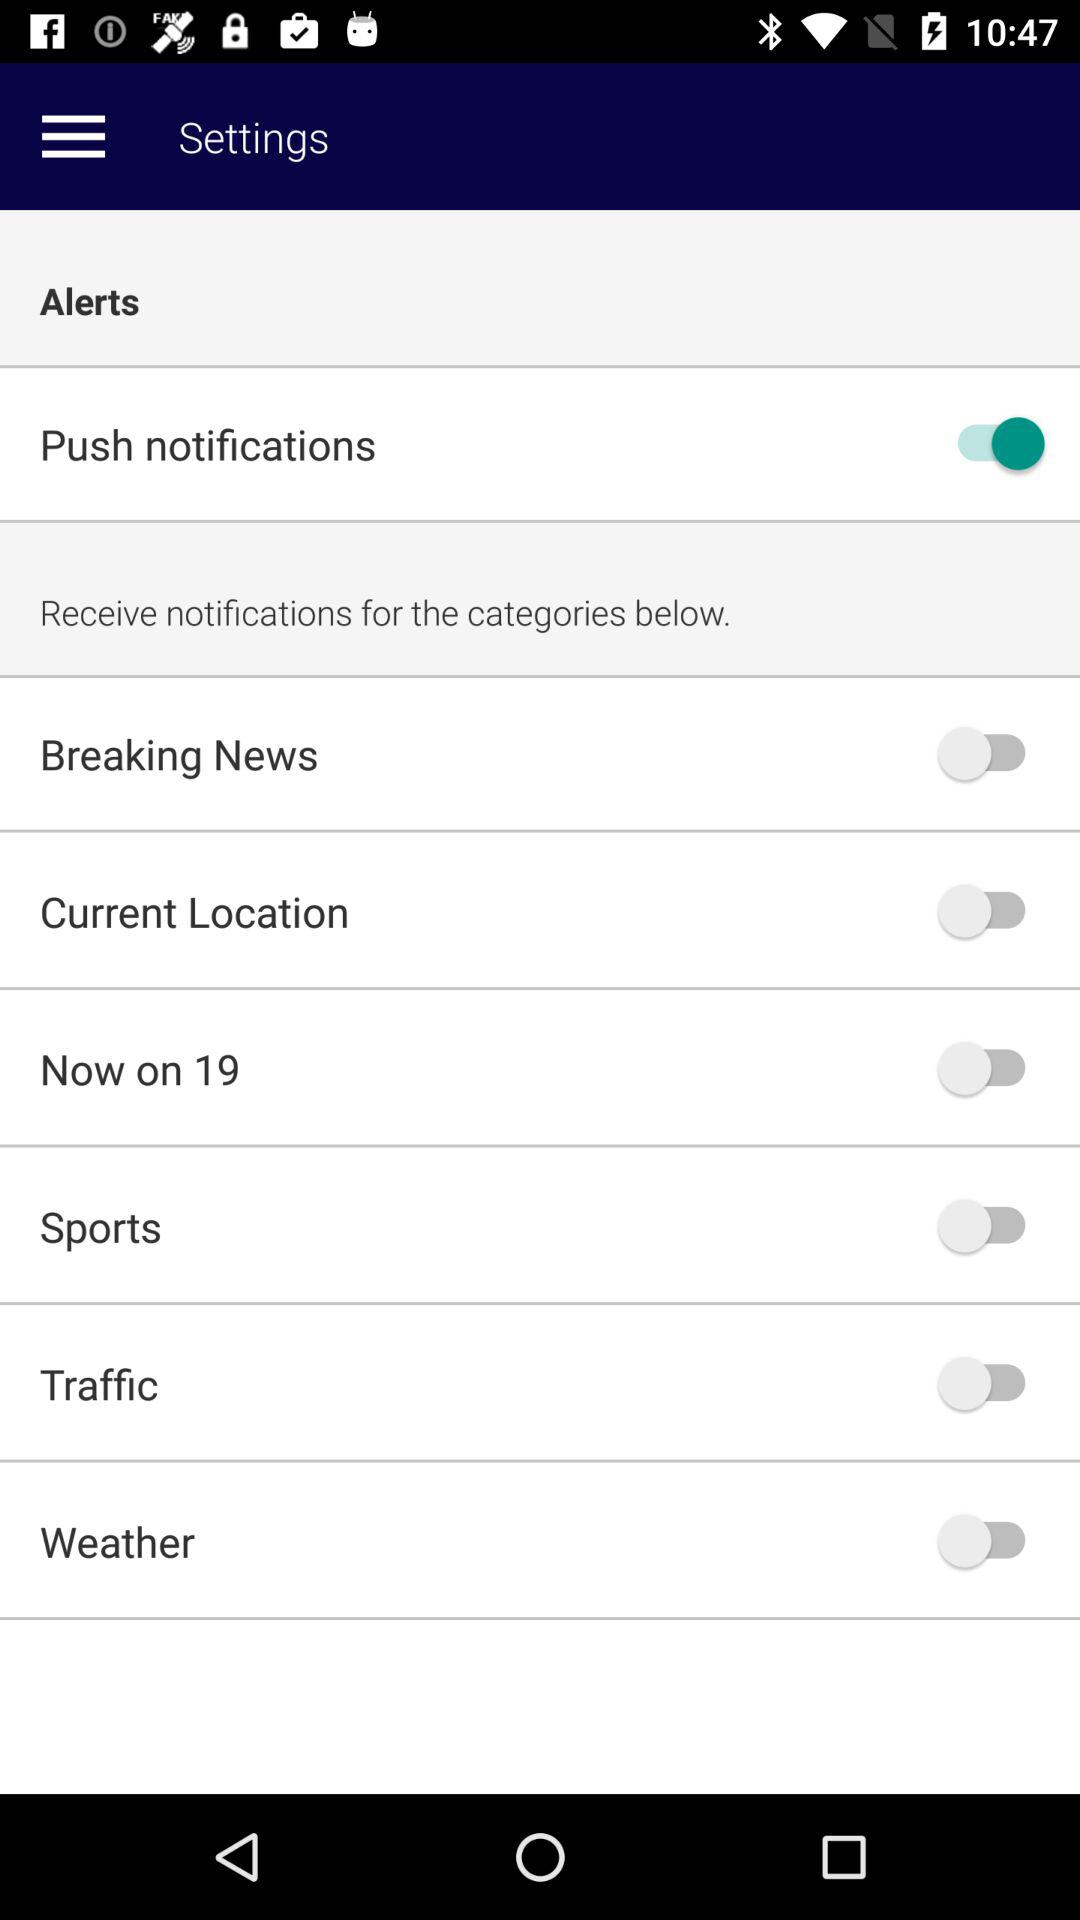What is the status of "Breaking News"? The status of "Breaking News" is "off". 